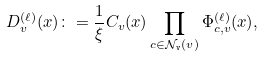Convert formula to latex. <formula><loc_0><loc_0><loc_500><loc_500>D _ { v } ^ { ( \ell ) } ( x ) \colon = \frac { 1 } { \xi } C _ { v } ( x ) \prod _ { c \in \mathcal { N } _ { \tt v } ( v ) } \Phi _ { c , v } ^ { ( \ell ) } ( x ) ,</formula> 